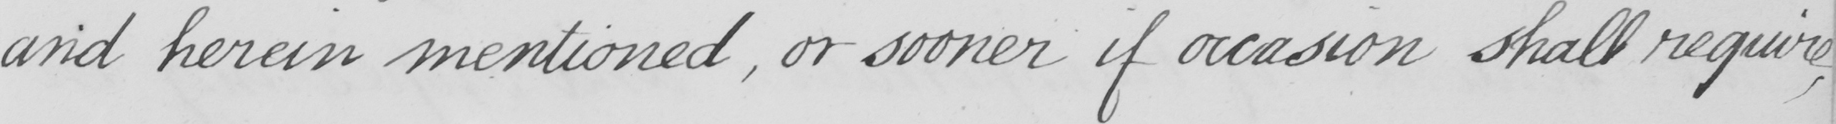What is written in this line of handwriting? and herein mentioned , or sooner if occasion shall require 